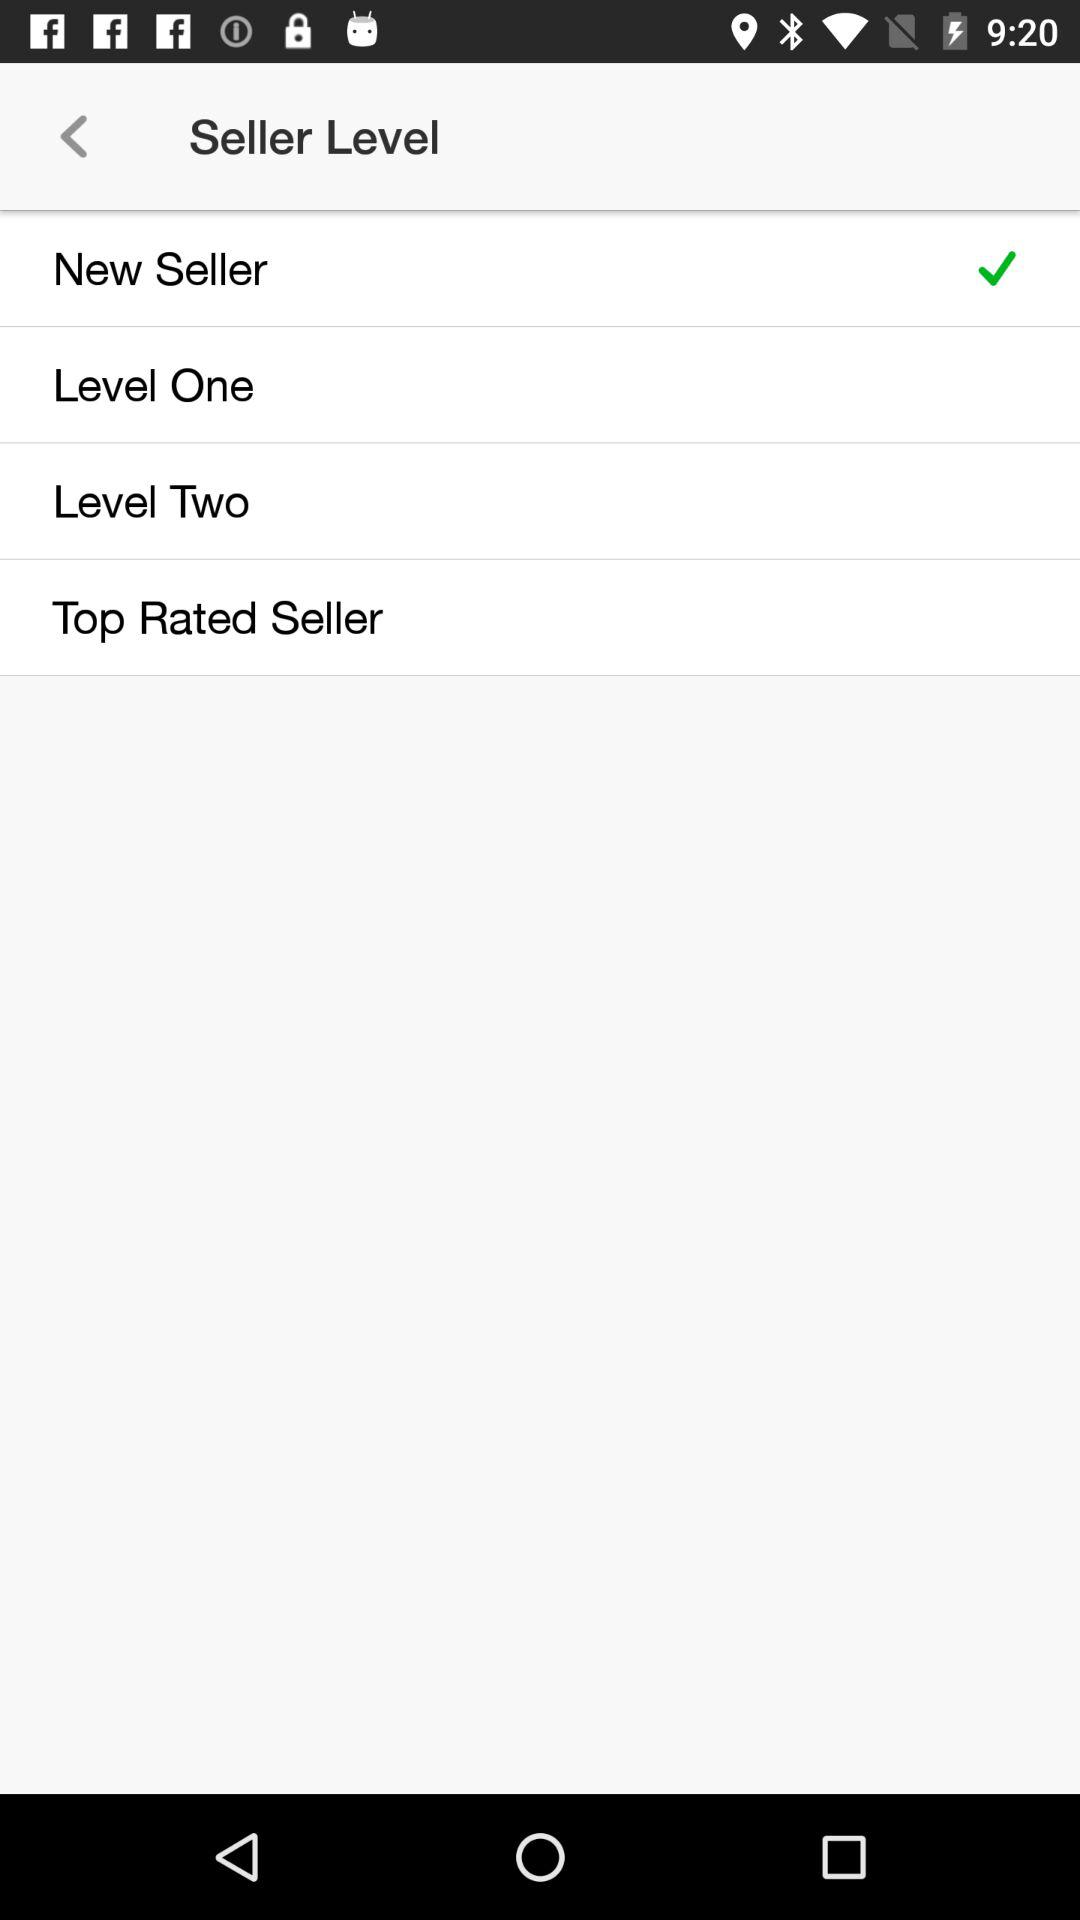Is Level One selected?
When the provided information is insufficient, respond with <no answer>. <no answer> 